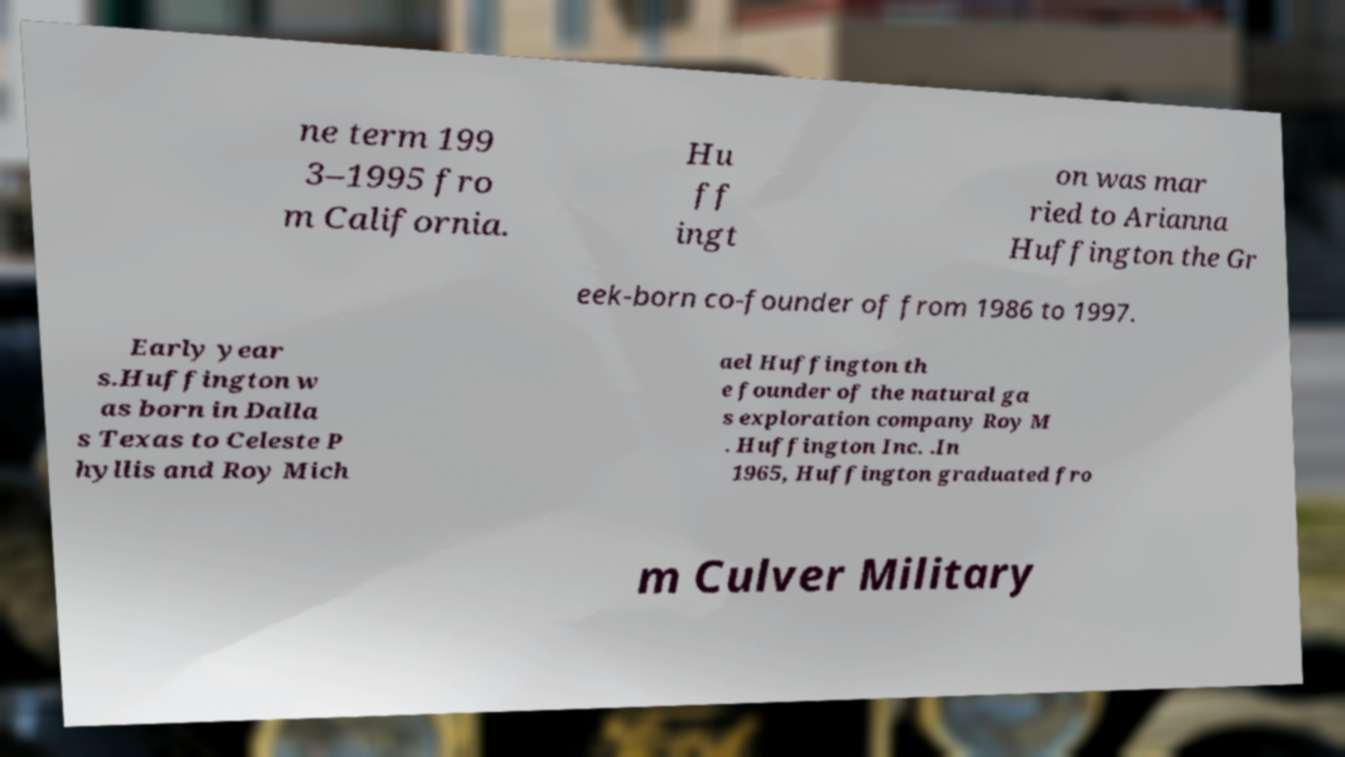Please read and relay the text visible in this image. What does it say? ne term 199 3–1995 fro m California. Hu ff ingt on was mar ried to Arianna Huffington the Gr eek-born co-founder of from 1986 to 1997. Early year s.Huffington w as born in Dalla s Texas to Celeste P hyllis and Roy Mich ael Huffington th e founder of the natural ga s exploration company Roy M . Huffington Inc. .In 1965, Huffington graduated fro m Culver Military 